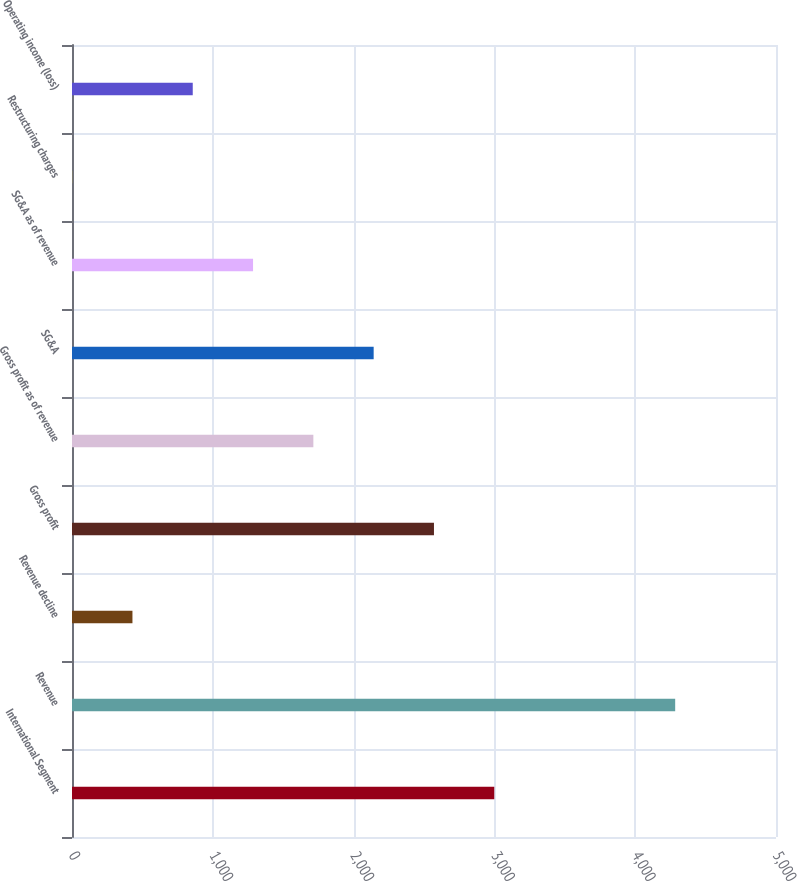Convert chart to OTSL. <chart><loc_0><loc_0><loc_500><loc_500><bar_chart><fcel>International Segment<fcel>Revenue<fcel>Revenue decline<fcel>Gross profit<fcel>Gross profit as of revenue<fcel>SG&A<fcel>SG&A as of revenue<fcel>Restructuring charges<fcel>Operating income (loss)<nl><fcel>2999.1<fcel>4284<fcel>429.3<fcel>2570.8<fcel>1714.2<fcel>2142.5<fcel>1285.9<fcel>1<fcel>857.6<nl></chart> 